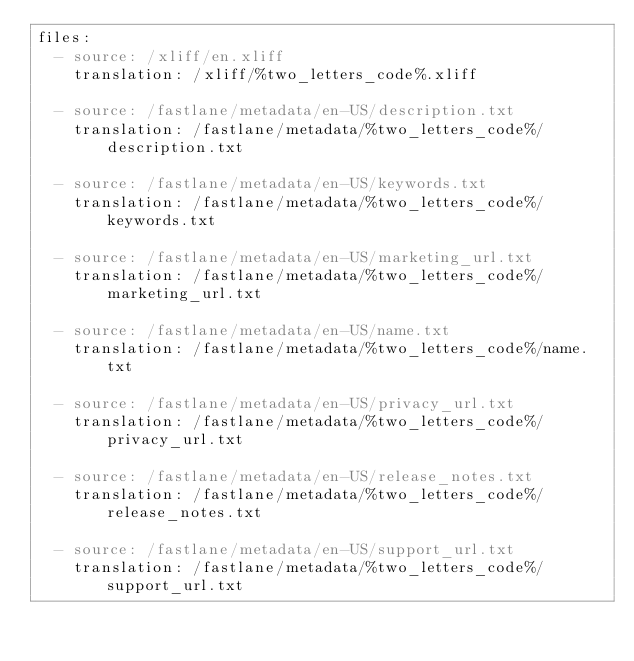<code> <loc_0><loc_0><loc_500><loc_500><_YAML_>files:
  - source: /xliff/en.xliff
    translation: /xliff/%two_letters_code%.xliff

  - source: /fastlane/metadata/en-US/description.txt
    translation: /fastlane/metadata/%two_letters_code%/description.txt

  - source: /fastlane/metadata/en-US/keywords.txt
    translation: /fastlane/metadata/%two_letters_code%/keywords.txt

  - source: /fastlane/metadata/en-US/marketing_url.txt
    translation: /fastlane/metadata/%two_letters_code%/marketing_url.txt

  - source: /fastlane/metadata/en-US/name.txt
    translation: /fastlane/metadata/%two_letters_code%/name.txt

  - source: /fastlane/metadata/en-US/privacy_url.txt
    translation: /fastlane/metadata/%two_letters_code%/privacy_url.txt

  - source: /fastlane/metadata/en-US/release_notes.txt
    translation: /fastlane/metadata/%two_letters_code%/release_notes.txt

  - source: /fastlane/metadata/en-US/support_url.txt
    translation: /fastlane/metadata/%two_letters_code%/support_url.txt
</code> 